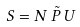Convert formula to latex. <formula><loc_0><loc_0><loc_500><loc_500>S = N \, \tilde { P } \, U</formula> 